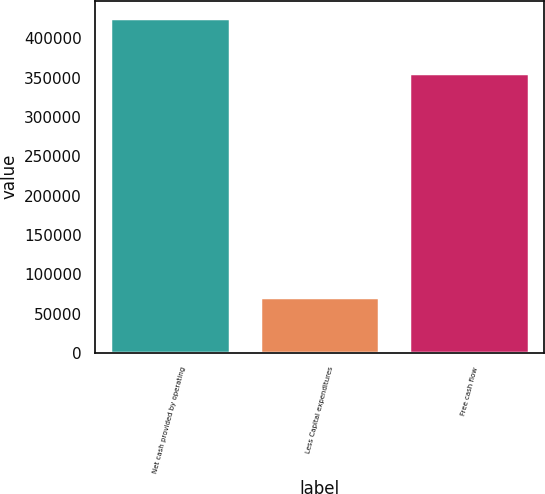<chart> <loc_0><loc_0><loc_500><loc_500><bar_chart><fcel>Net cash provided by operating<fcel>Less Capital expenditures<fcel>Free cash flow<nl><fcel>426301<fcel>70903<fcel>355398<nl></chart> 